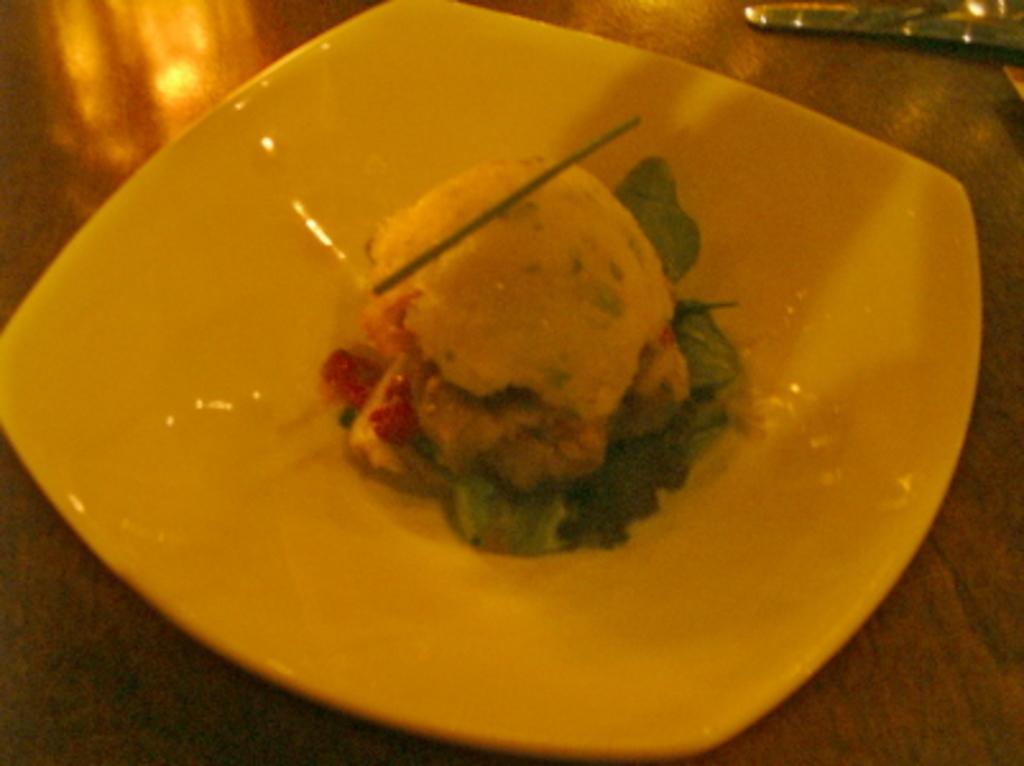How would you summarize this image in a sentence or two? In the picture we can see some food item which is in white color plate. 